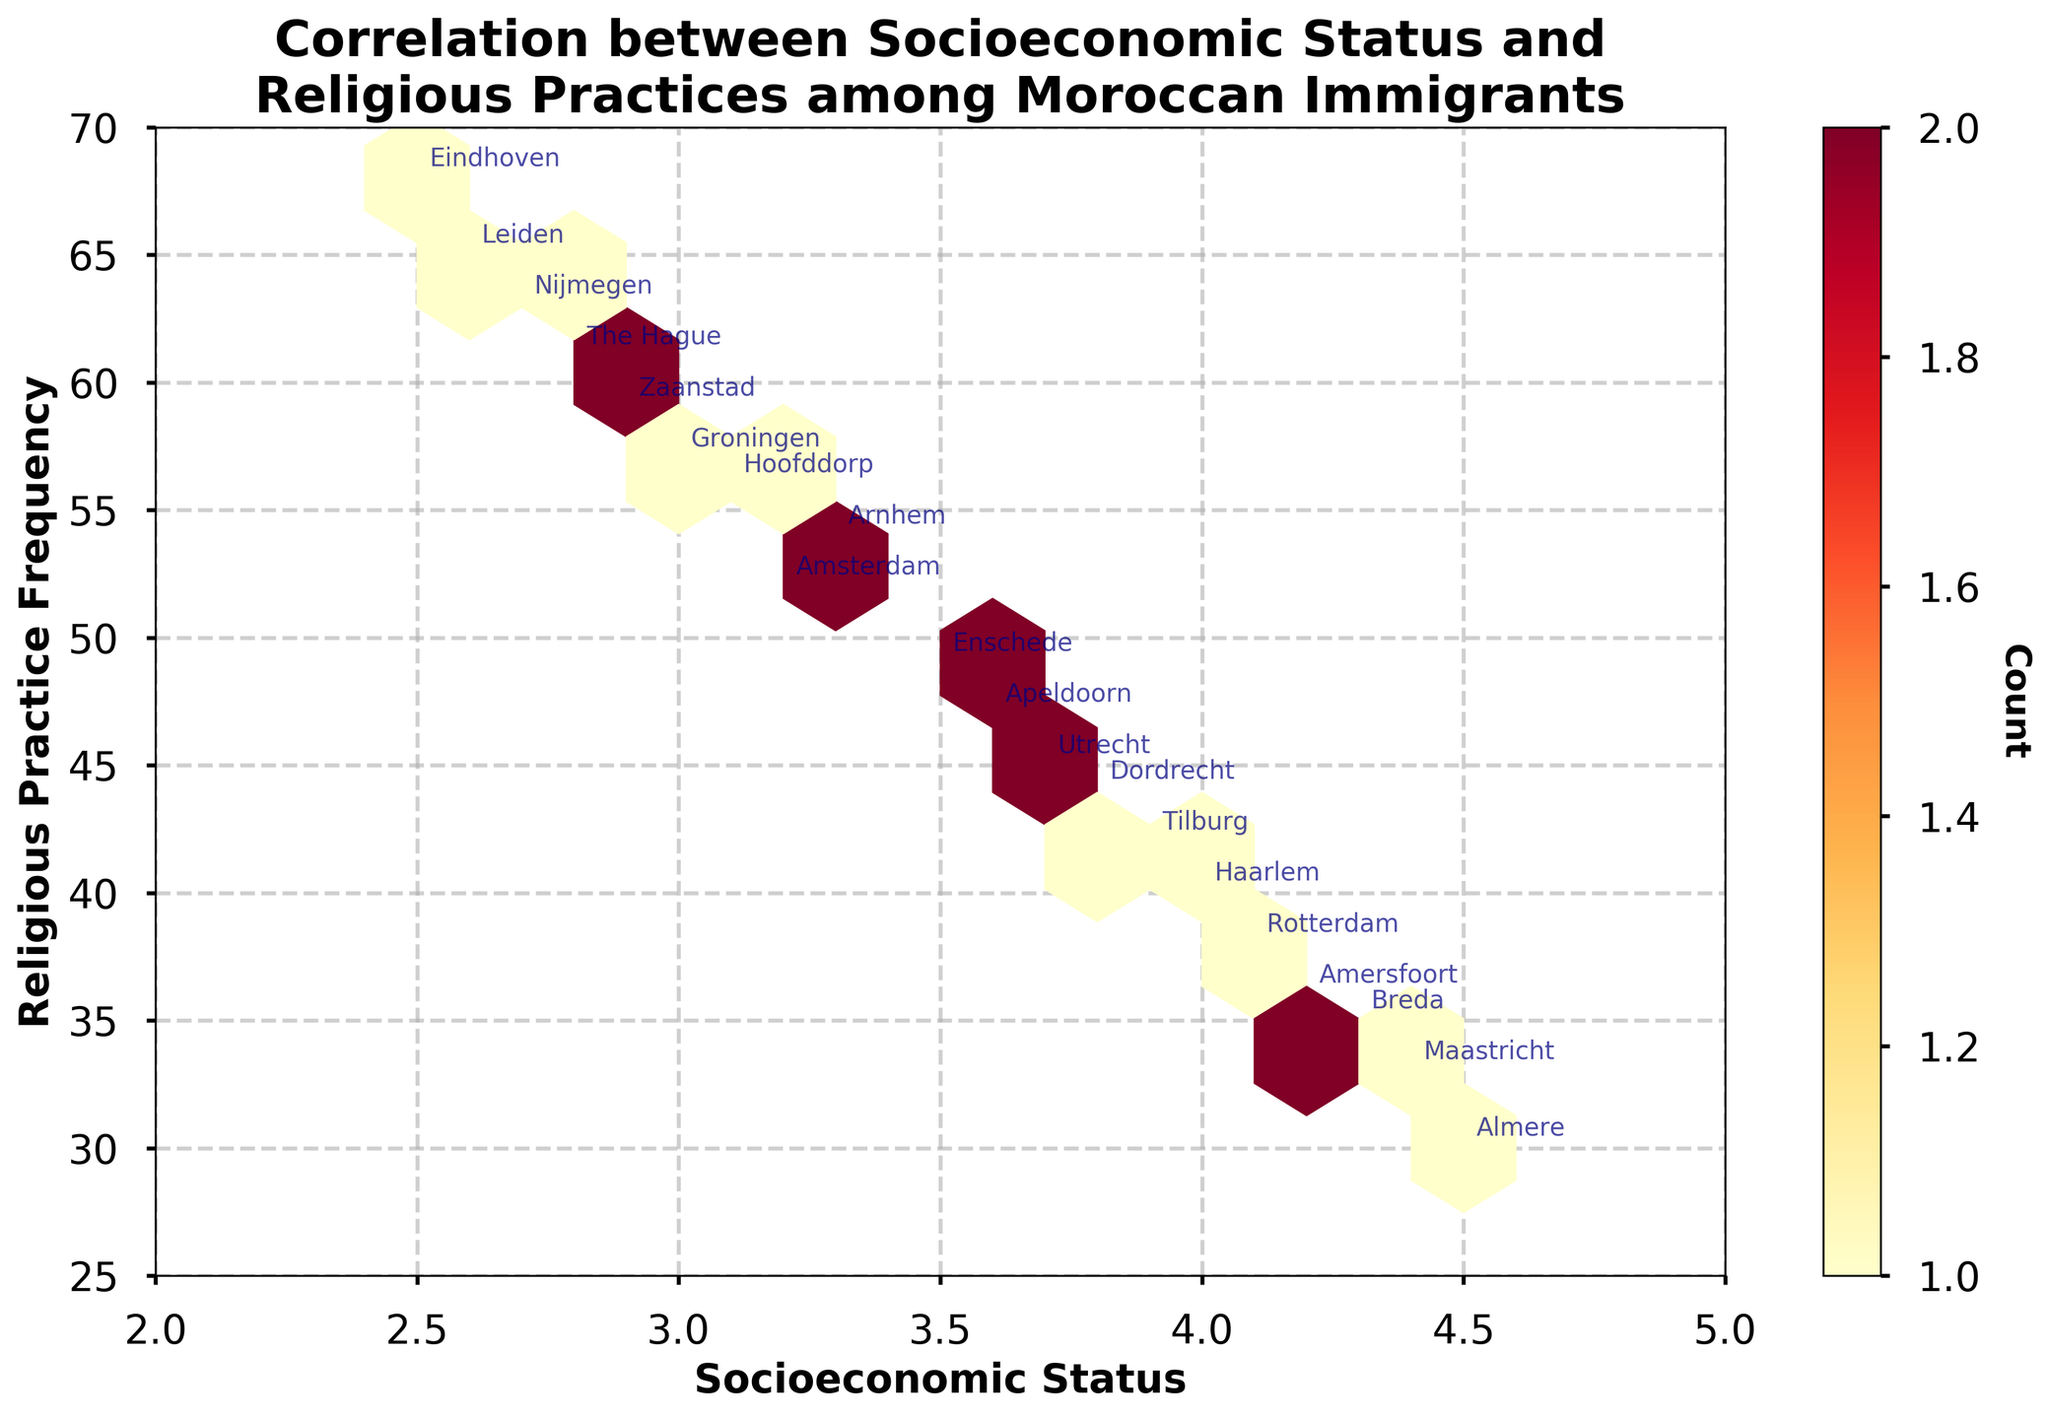What is the title of the figure? The title is generally found at the top of the figure, centered, and it describes the content or the purpose of the figure. Here, the title is "Correlation between Socioeconomic Status and Religious Practices among Moroccan Immigrants".
Answer: Correlation between Socioeconomic Status and Religious Practices among Moroccan Immigrants What are the labels for the x-axis and y-axis? The axes labels are indicated along the respective axes to represent the variables being plotted. In this figure, "Socioeconomic Status" is the x-axis label, and "Religious Practice Frequency" is the y-axis label.
Answer: Socioeconomic Status and Religious Practice Frequency How many hexagonal bins are there in the plot? To first identify the figure as a Hexbin plot is crucial. We then observe that the figure is divided into hexagonal bins. Counting the bins might vary slightly due to visual overlap or clustering, but an estimated count would give around 10 bins.
Answer: Approximately 10 Which city has the highest frequency of religious practices? By analyzing the scatter points (annotated text for the cities), we identify the highest "Religious Practice Frequency" position on the y-axis, which is 68, and the associated city is "Eindhoven".
Answer: Eindhoven Which city has the lowest socioeconomic status? Analyze the x-axis positions of the data points to identify the city with the lowest "Socioeconomic Status," which is a value of 2.5. Therefore, the city is "Eindhoven".
Answer: Eindhoven What is the general trend between socioeconomic status and religious practice frequency? A general trend on a Hexbin plot can be inferred from the density and coloring of hexagonal bins. Observing from bottom-left to top-right or vice versa, we can identify whether there is a negative or positive correlation. Here we see a slight downward trend, indicating a negative correlation, meaning that as socioeconomic status increases, religious practice frequency decreases slightly.
Answer: Negative correlation What is the relationship between population density and the density of hexagonal bins? Although not directly represented on the plot, indirect inferences can be made through the city annotations. Cities with high Population Density (like "The Hague" and "Leiden") generally exhibit higher concentrations in hexagonal bin clusters.
Answer: Higher population density correlates with higher bin density How many cities have socioeconomic status above 4.0? Observing the x-axis, count all cities labeled above the value of 4.0. Cities include "Rotterdam," "Almere," "Breda," "Amersfoort," and "Maastricht," thus making it five cities.
Answer: Five cities Which city has the closest balance between socioeconomic status and religious practice frequency? Identifying the city closest to the center x-y point of the plot, ideally where the lines representing the middle values cross, indicating a balanced representation. "Utrecht," with coordinates x=3.7 and y=45, appears closest.
Answer: Utrecht What pattern appears in the color distribution of hexagonal bins in density? Observing the color gradient on the Hexbin plot, it transitions from light yellow to dark red, where darker colors indicate higher density or frequency. The central bins are darker, showing higher concentrations and thus more frequent data occurrence.
Answer: Central bins are darker due to higher frequency 